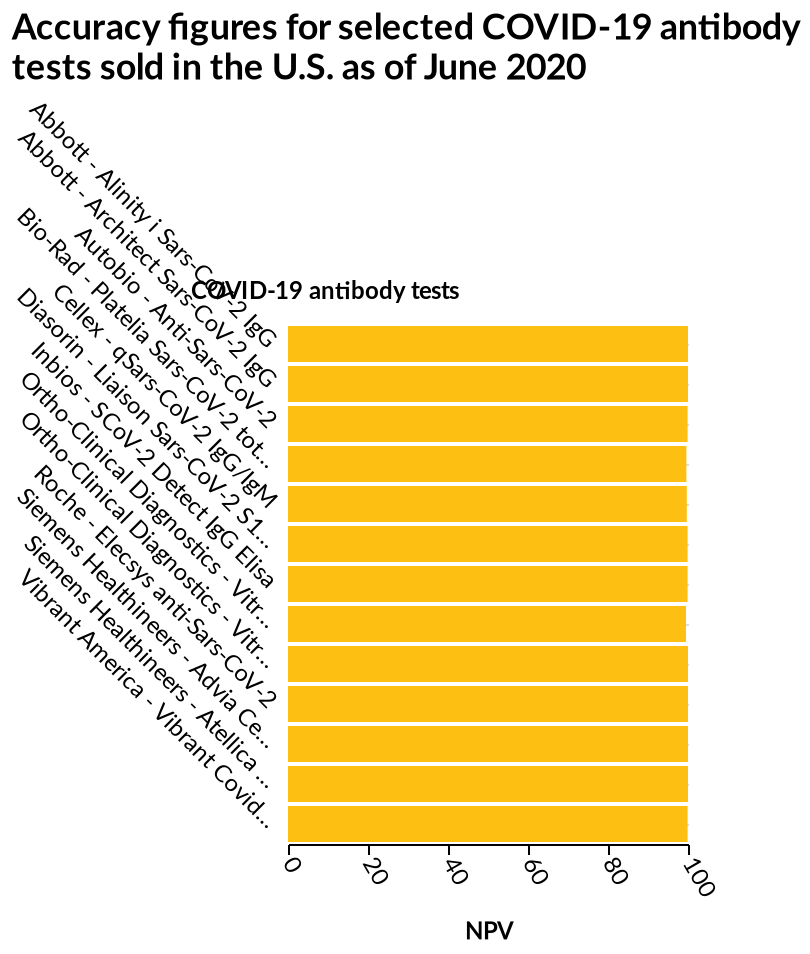<image>
When was the data collected for the bar chart? The data for the bar chart was collected as of June 2020. Based on the chart, what can be concluded about the tests' accuracy? Based on the chart, it can be concluded that all the tests have a 100% accuracy rate since the bars representing them are completed to 100%. Are all the tests indicated on the chart 100% accurate? Yes, all the tests indicated on the chart are 100% accurate according to the completed bars. 